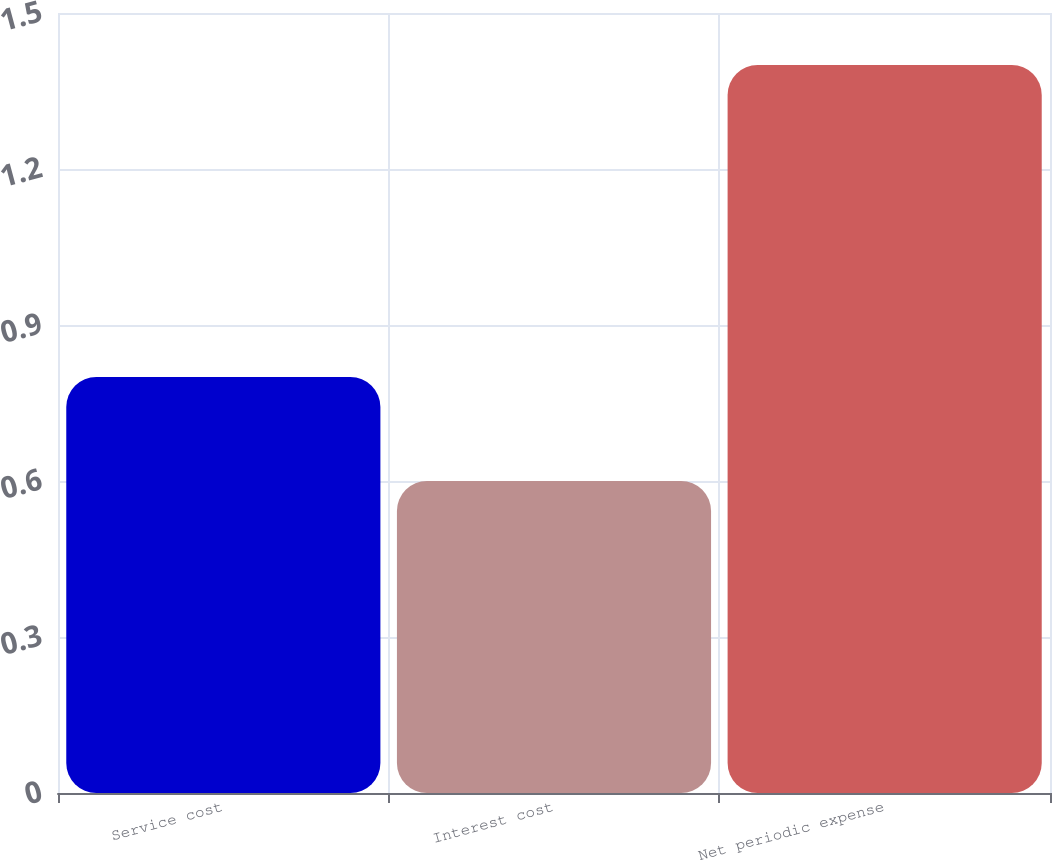Convert chart to OTSL. <chart><loc_0><loc_0><loc_500><loc_500><bar_chart><fcel>Service cost<fcel>Interest cost<fcel>Net periodic expense<nl><fcel>0.8<fcel>0.6<fcel>1.4<nl></chart> 